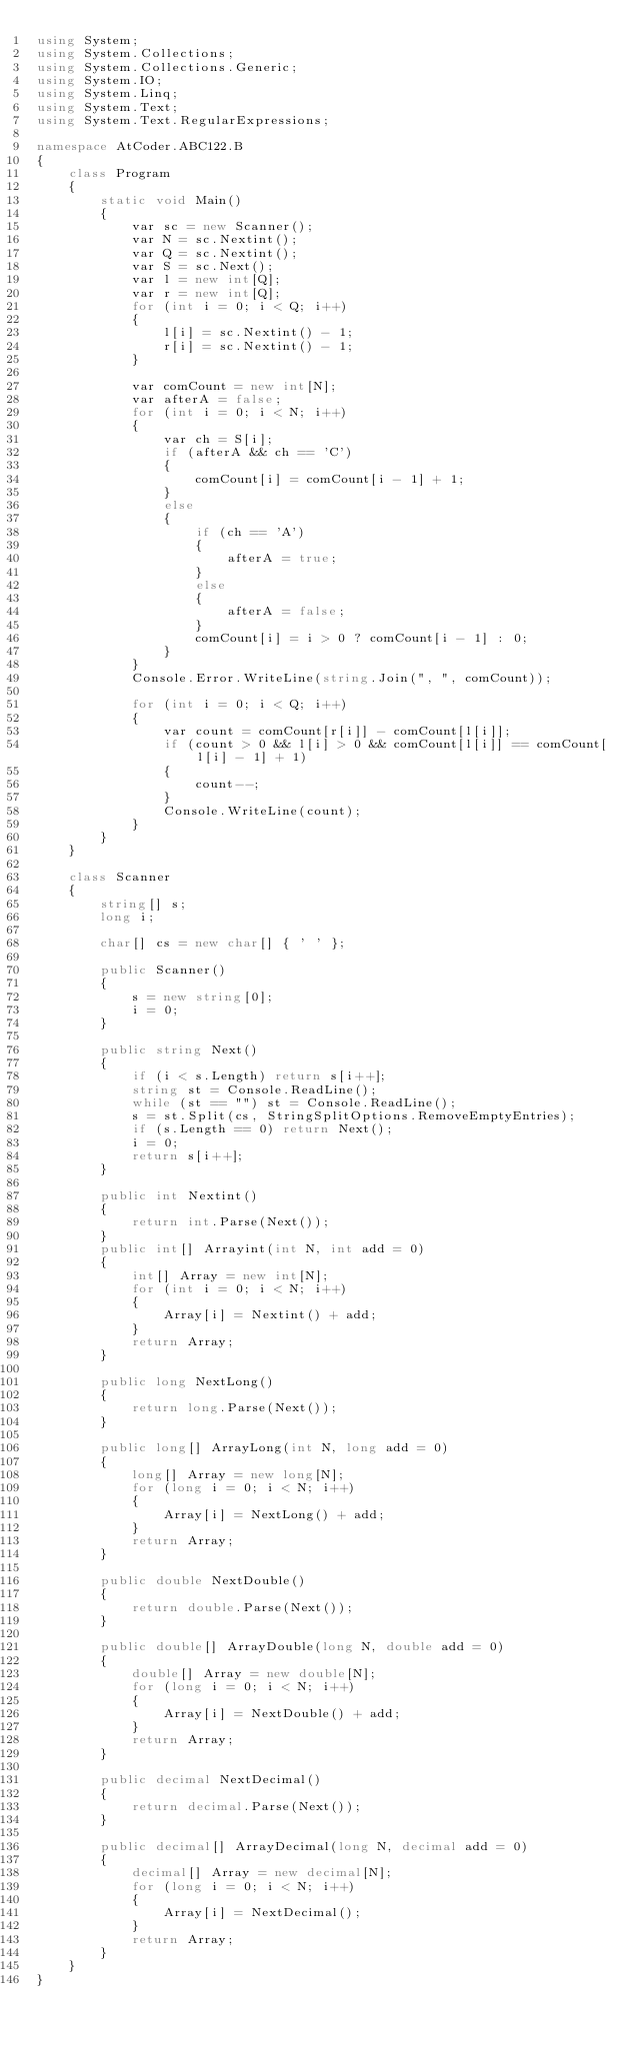Convert code to text. <code><loc_0><loc_0><loc_500><loc_500><_C#_>using System;
using System.Collections;
using System.Collections.Generic;
using System.IO;
using System.Linq;
using System.Text;
using System.Text.RegularExpressions;

namespace AtCoder.ABC122.B
{
    class Program
    {
        static void Main()
        {
            var sc = new Scanner();
            var N = sc.Nextint();
            var Q = sc.Nextint();
            var S = sc.Next();
            var l = new int[Q];
            var r = new int[Q];
            for (int i = 0; i < Q; i++)
            {
                l[i] = sc.Nextint() - 1;
                r[i] = sc.Nextint() - 1;
            }

            var comCount = new int[N];
            var afterA = false;
            for (int i = 0; i < N; i++)
            {
                var ch = S[i];
                if (afterA && ch == 'C')
                {
                    comCount[i] = comCount[i - 1] + 1;
                }
                else
                {
                    if (ch == 'A')
                    {
                        afterA = true;
                    }
                    else
                    {
                        afterA = false;
                    }
                    comCount[i] = i > 0 ? comCount[i - 1] : 0;
                }
            }
            Console.Error.WriteLine(string.Join(", ", comCount));

            for (int i = 0; i < Q; i++)
            {
                var count = comCount[r[i]] - comCount[l[i]];
                if (count > 0 && l[i] > 0 && comCount[l[i]] == comCount[l[i] - 1] + 1)
                {
                    count--;
                }
                Console.WriteLine(count);
            }
        }
    }

    class Scanner
    {
        string[] s;
        long i;

        char[] cs = new char[] { ' ' };

        public Scanner()
        {
            s = new string[0];
            i = 0;
        }

        public string Next()
        {
            if (i < s.Length) return s[i++];
            string st = Console.ReadLine();
            while (st == "") st = Console.ReadLine();
            s = st.Split(cs, StringSplitOptions.RemoveEmptyEntries);
            if (s.Length == 0) return Next();
            i = 0;
            return s[i++];
        }

        public int Nextint()
        {
            return int.Parse(Next());
        }
        public int[] Arrayint(int N, int add = 0)
        {
            int[] Array = new int[N];
            for (int i = 0; i < N; i++)
            {
                Array[i] = Nextint() + add;
            }
            return Array;
        }

        public long NextLong()
        {
            return long.Parse(Next());
        }

        public long[] ArrayLong(int N, long add = 0)
        {
            long[] Array = new long[N];
            for (long i = 0; i < N; i++)
            {
                Array[i] = NextLong() + add;
            }
            return Array;
        }

        public double NextDouble()
        {
            return double.Parse(Next());
        }

        public double[] ArrayDouble(long N, double add = 0)
        {
            double[] Array = new double[N];
            for (long i = 0; i < N; i++)
            {
                Array[i] = NextDouble() + add;
            }
            return Array;
        }

        public decimal NextDecimal()
        {
            return decimal.Parse(Next());
        }

        public decimal[] ArrayDecimal(long N, decimal add = 0)
        {
            decimal[] Array = new decimal[N];
            for (long i = 0; i < N; i++)
            {
                Array[i] = NextDecimal();
            }
            return Array;
        }
    }
}
</code> 